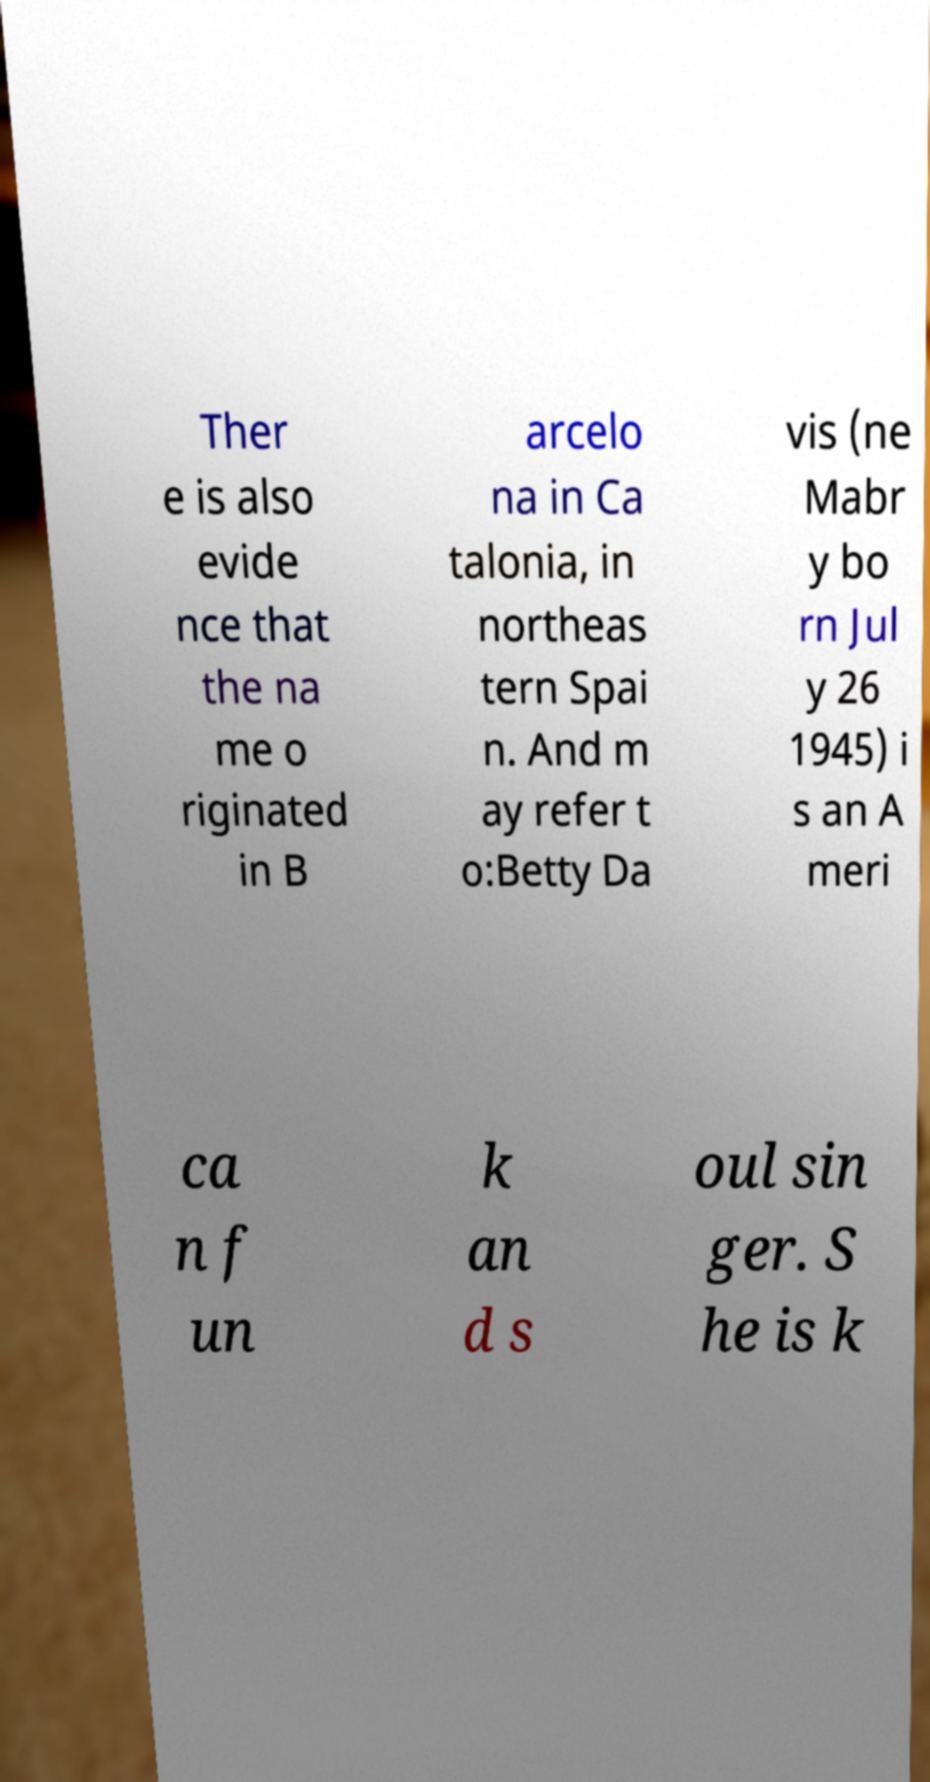What messages or text are displayed in this image? I need them in a readable, typed format. Ther e is also evide nce that the na me o riginated in B arcelo na in Ca talonia, in northeas tern Spai n. And m ay refer t o:Betty Da vis (ne Mabr y bo rn Jul y 26 1945) i s an A meri ca n f un k an d s oul sin ger. S he is k 